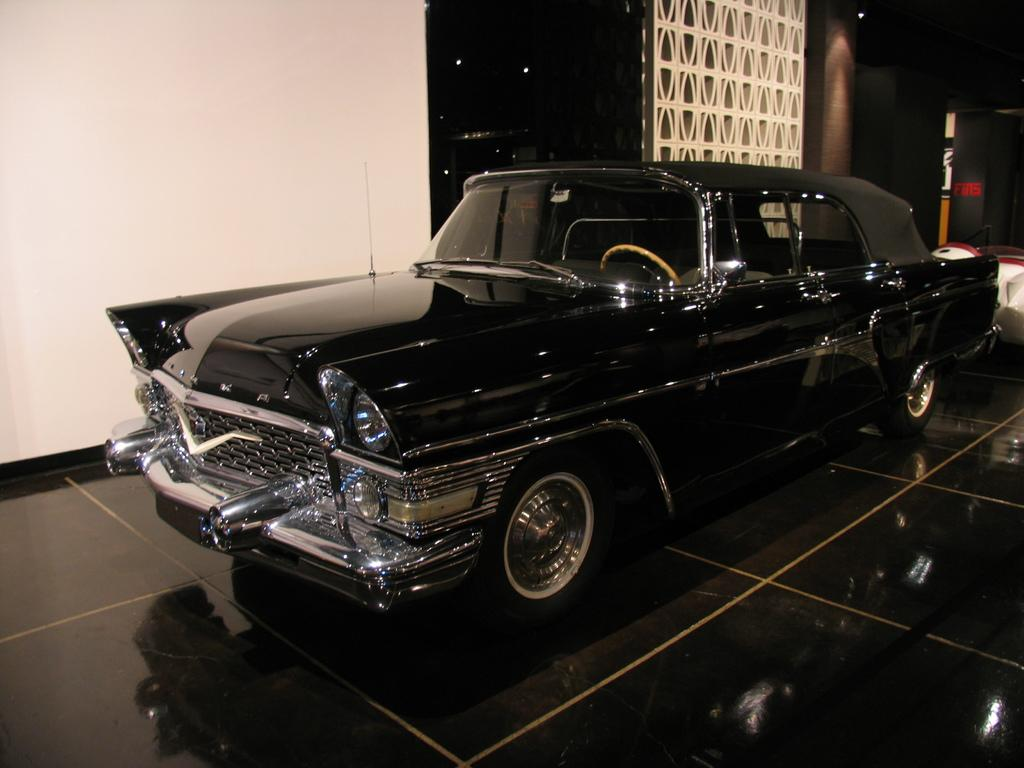What is the main subject of the image? The main subject of the image is a car. Where is the car located in the image? The car is on the floor in the image. What can be seen behind the car in the image? There is a wall behind the car in the image. What type of soup is being served on the canvas in the image? There is no soup or canvas present in the image; it features a car on the floor with a wall behind it. 